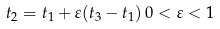<formula> <loc_0><loc_0><loc_500><loc_500>t _ { 2 } = t _ { 1 } + \varepsilon ( t _ { 3 } - t _ { 1 } ) \, 0 < \varepsilon < 1</formula> 